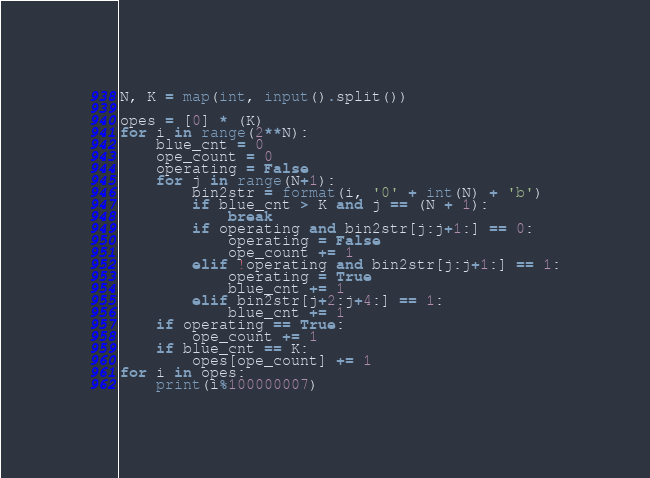Convert code to text. <code><loc_0><loc_0><loc_500><loc_500><_Python_>N, K = map(int, input().split())

opes = [0] * (K)
for i in range(2**N):
    blue_cnt = 0
    ope_count = 0
    operating = False
    for j in range(N+1):
        bin2str = format(i, '0' + int(N) + 'b')
        if blue_cnt > K and j == (N + 1):
            break
        if operating and bin2str[j:j+1:] == 0:
            operating = False
            ope_count += 1
        elif !operating and bin2str[j:j+1:] == 1:
            operating = True
            blue_cnt += 1
        elif bin2str[j+2:j+4:] == 1:
            blue_cnt += 1
    if operating == True:
    	ope_count += 1
    if blue_cnt == K:
        opes[ope_count] += 1
for i in opes:
    print(i%100000007)
</code> 